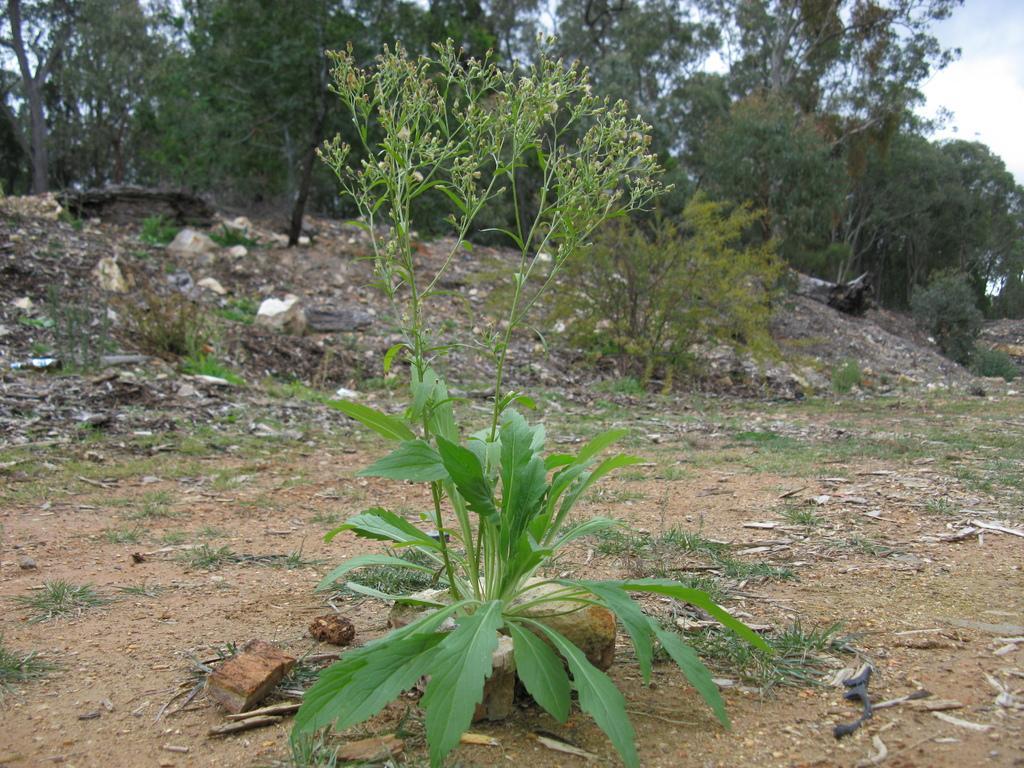How would you summarize this image in a sentence or two? In the image there is a land with a lot dust and in between the land there are few plants and in the background there are many trees. 